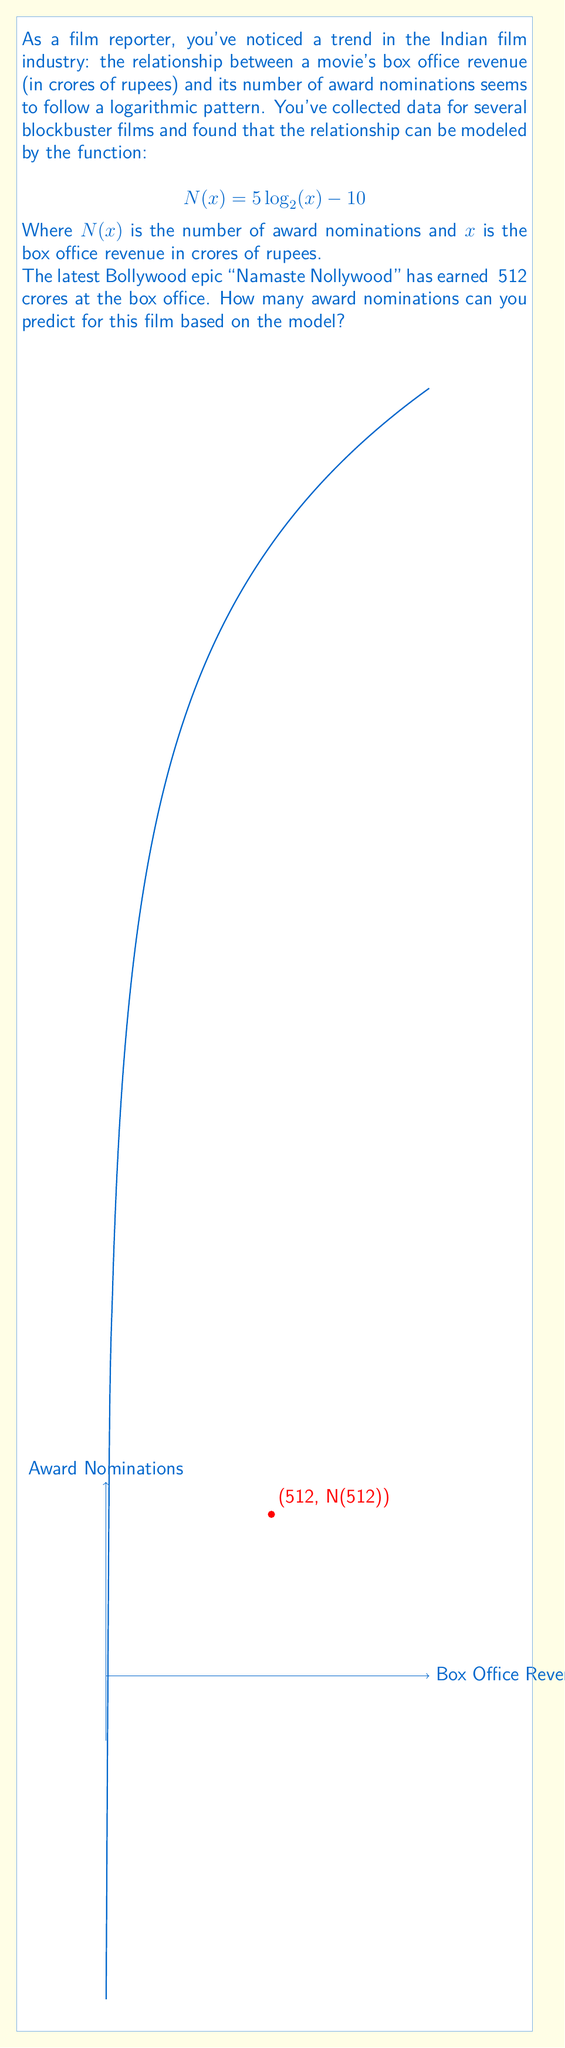What is the answer to this math problem? Let's approach this step-by-step:

1) We are given the function: $N(x) = 5 \log_2(x) - 10$

2) We need to find $N(512)$, as the movie earned ₹512 crores.

3) Let's substitute $x = 512$ into the function:

   $N(512) = 5 \log_2(512) - 10$

4) Now, we need to calculate $\log_2(512)$:
   
   $512 = 2^9$, so $\log_2(512) = 9$

5) Substituting this back into our equation:

   $N(512) = 5(9) - 10$

6) Now we can simply calculate:

   $N(512) = 45 - 10 = 35$

Therefore, based on this logarithmic model, we can predict that "Namaste Nollywood" will receive 35 award nominations.
Answer: 35 nominations 